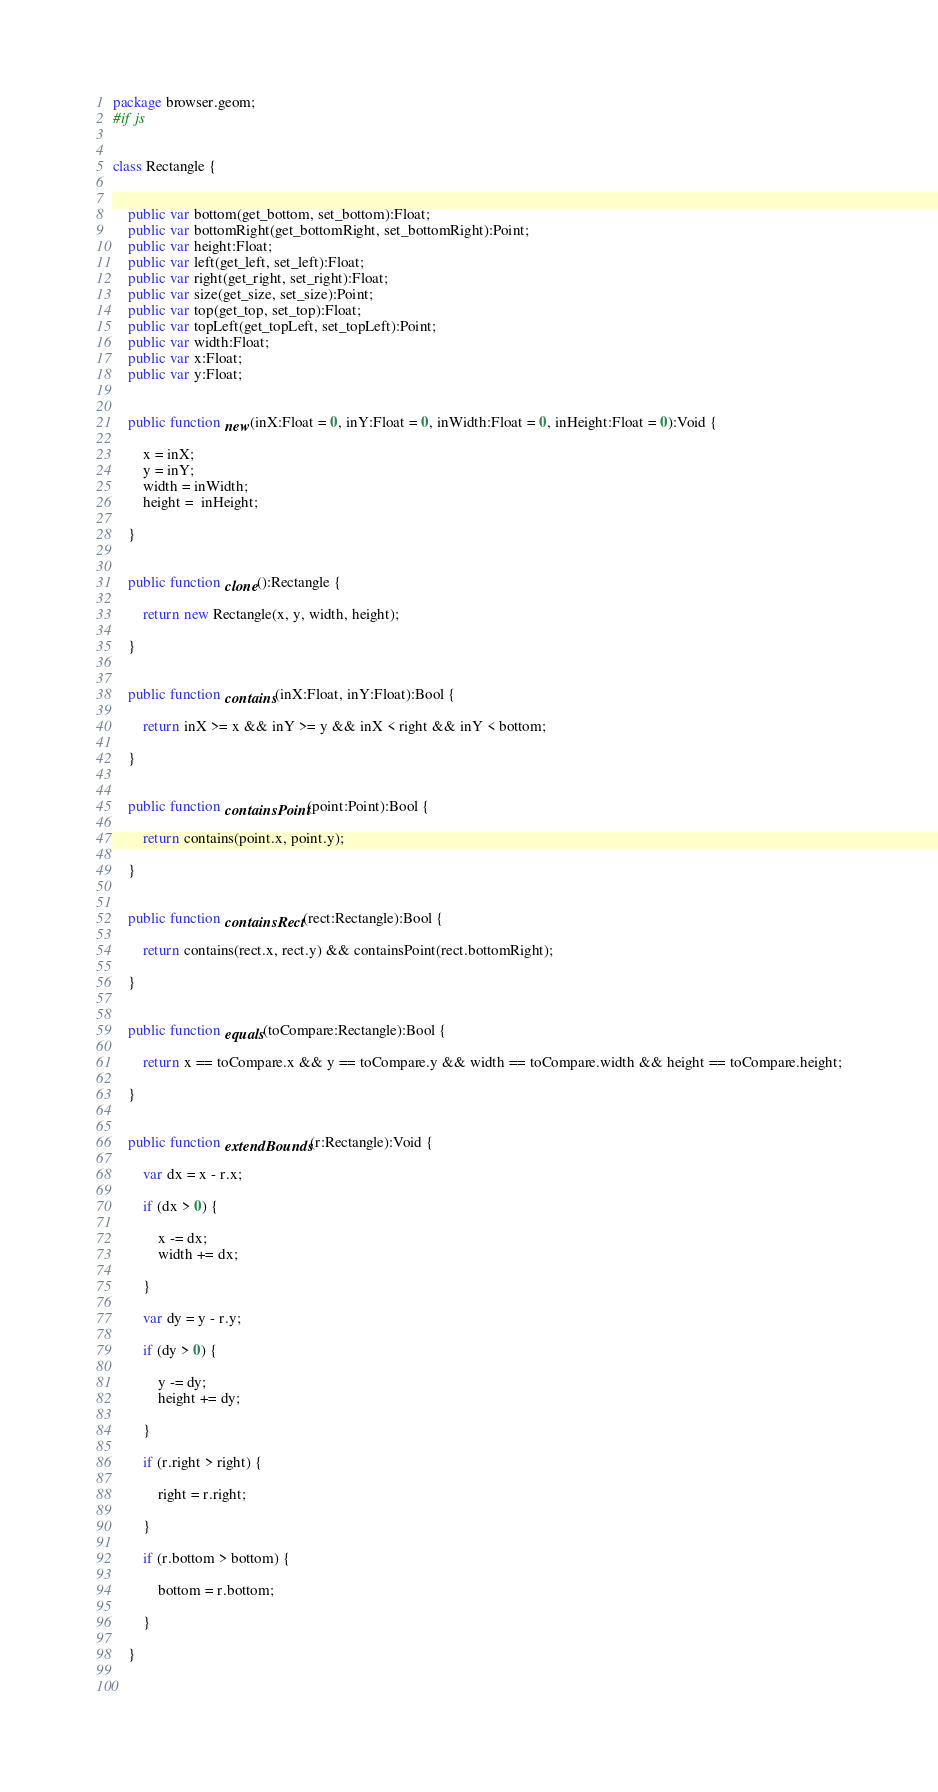Convert code to text. <code><loc_0><loc_0><loc_500><loc_500><_Haxe_>package browser.geom;
#if js


class Rectangle {
	
	
	public var bottom(get_bottom, set_bottom):Float;
	public var bottomRight(get_bottomRight, set_bottomRight):Point;
	public var height:Float;
	public var left(get_left, set_left):Float;
	public var right(get_right, set_right):Float;
	public var size(get_size, set_size):Point;
	public var top(get_top, set_top):Float;
	public var topLeft(get_topLeft, set_topLeft):Point;
	public var width:Float;
	public var x:Float;
	public var y:Float;
	
	
	public function new(inX:Float = 0, inY:Float = 0, inWidth:Float = 0, inHeight:Float = 0):Void {
		
		x = inX;
		y = inY;
		width = inWidth;
		height =  inHeight;
		
	}
	
	
	public function clone():Rectangle {
		
		return new Rectangle(x, y, width, height);
		
	}
	
	
	public function contains(inX:Float, inY:Float):Bool {
		
		return inX >= x && inY >= y && inX < right && inY < bottom;
		
	}
	
	
	public function containsPoint(point:Point):Bool {
		
		return contains(point.x, point.y);
		
	}
	
	
	public function containsRect(rect:Rectangle):Bool {
		
		return contains(rect.x, rect.y) && containsPoint(rect.bottomRight);
		
	}
	
	
	public function equals(toCompare:Rectangle):Bool {
		
		return x == toCompare.x && y == toCompare.y && width == toCompare.width && height == toCompare.height;
		
	}
	
	
	public function extendBounds(r:Rectangle):Void {
		
		var dx = x - r.x;
		
		if (dx > 0) {
			
			x -= dx;
			width += dx;
			
		}
		
		var dy = y - r.y;
		
		if (dy > 0) {
			
			y -= dy;
			height += dy;
			
		}
		
		if (r.right > right) {
			
			right = r.right;
			
		}
		
		if (r.bottom > bottom) {
			
			bottom = r.bottom;
			
		}
		
	}
	
	</code> 